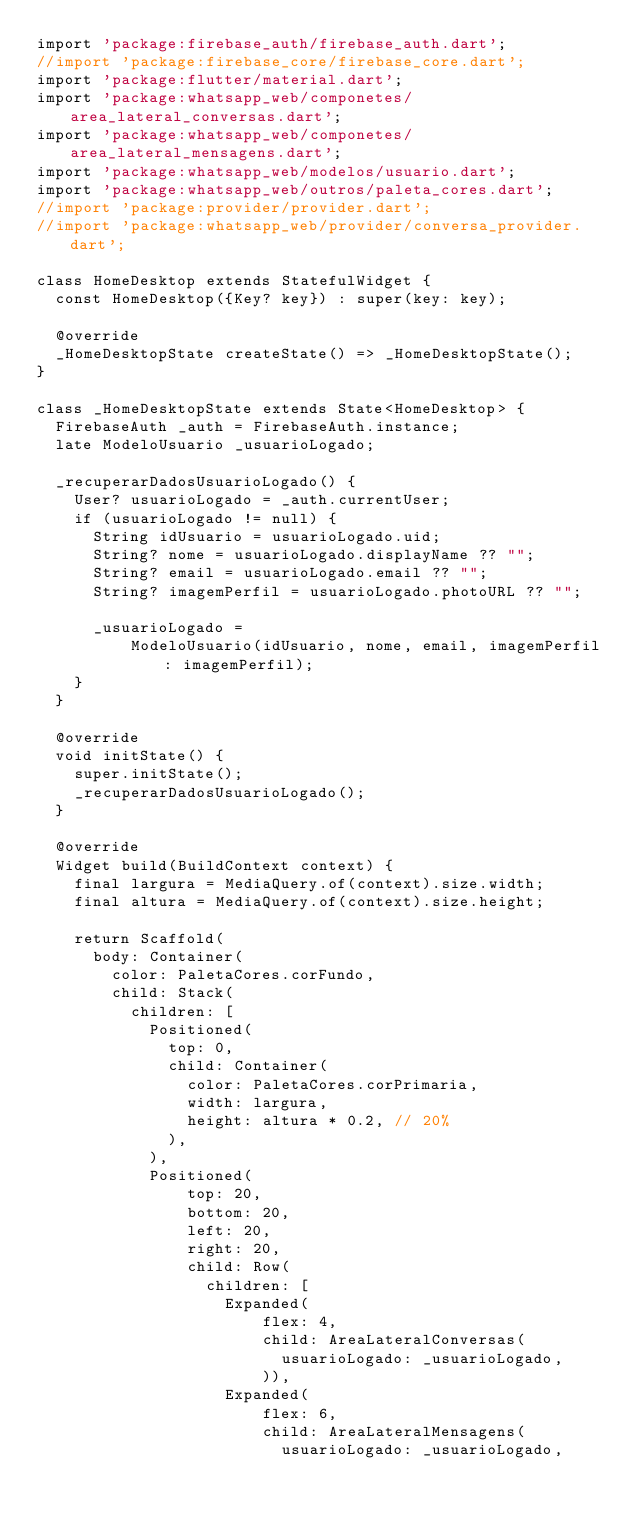Convert code to text. <code><loc_0><loc_0><loc_500><loc_500><_Dart_>import 'package:firebase_auth/firebase_auth.dart';
//import 'package:firebase_core/firebase_core.dart';
import 'package:flutter/material.dart';
import 'package:whatsapp_web/componetes/area_lateral_conversas.dart';
import 'package:whatsapp_web/componetes/area_lateral_mensagens.dart';
import 'package:whatsapp_web/modelos/usuario.dart';
import 'package:whatsapp_web/outros/paleta_cores.dart';
//import 'package:provider/provider.dart';
//import 'package:whatsapp_web/provider/conversa_provider.dart';

class HomeDesktop extends StatefulWidget {
  const HomeDesktop({Key? key}) : super(key: key);

  @override
  _HomeDesktopState createState() => _HomeDesktopState();
}

class _HomeDesktopState extends State<HomeDesktop> {
  FirebaseAuth _auth = FirebaseAuth.instance;
  late ModeloUsuario _usuarioLogado;

  _recuperarDadosUsuarioLogado() {
    User? usuarioLogado = _auth.currentUser;
    if (usuarioLogado != null) {
      String idUsuario = usuarioLogado.uid;
      String? nome = usuarioLogado.displayName ?? "";
      String? email = usuarioLogado.email ?? "";
      String? imagemPerfil = usuarioLogado.photoURL ?? "";

      _usuarioLogado =
          ModeloUsuario(idUsuario, nome, email, imagemPerfil: imagemPerfil);
    }
  }

  @override
  void initState() {
    super.initState();
    _recuperarDadosUsuarioLogado();
  }

  @override
  Widget build(BuildContext context) {
    final largura = MediaQuery.of(context).size.width;
    final altura = MediaQuery.of(context).size.height;

    return Scaffold(
      body: Container(
        color: PaletaCores.corFundo,
        child: Stack(
          children: [
            Positioned(
              top: 0,
              child: Container(
                color: PaletaCores.corPrimaria,
                width: largura,
                height: altura * 0.2, // 20%
              ),
            ),
            Positioned(
                top: 20,
                bottom: 20,
                left: 20,
                right: 20,
                child: Row(
                  children: [
                    Expanded(
                        flex: 4,
                        child: AreaLateralConversas(
                          usuarioLogado: _usuarioLogado,
                        )),
                    Expanded(
                        flex: 6,
                        child: AreaLateralMensagens(
                          usuarioLogado: _usuarioLogado,</code> 